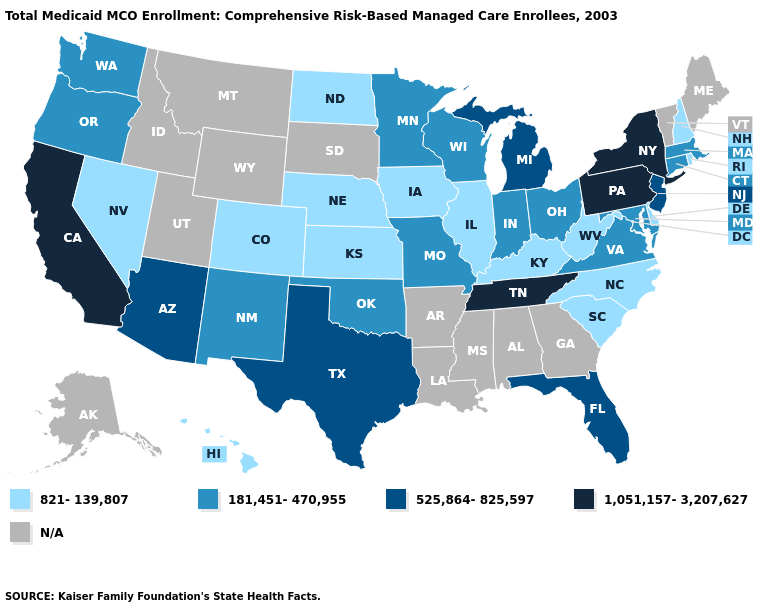Which states have the highest value in the USA?
Give a very brief answer. California, New York, Pennsylvania, Tennessee. Name the states that have a value in the range 525,864-825,597?
Give a very brief answer. Arizona, Florida, Michigan, New Jersey, Texas. Among the states that border Vermont , does New York have the highest value?
Concise answer only. Yes. What is the value of Nevada?
Answer briefly. 821-139,807. Does North Carolina have the lowest value in the USA?
Write a very short answer. Yes. Which states have the highest value in the USA?
Give a very brief answer. California, New York, Pennsylvania, Tennessee. What is the highest value in states that border Texas?
Short answer required. 181,451-470,955. What is the value of Alabama?
Keep it brief. N/A. What is the value of Arkansas?
Concise answer only. N/A. What is the value of Rhode Island?
Keep it brief. 821-139,807. Name the states that have a value in the range 525,864-825,597?
Keep it brief. Arizona, Florida, Michigan, New Jersey, Texas. What is the value of Arizona?
Write a very short answer. 525,864-825,597. Does New York have the lowest value in the Northeast?
Short answer required. No. Which states have the lowest value in the USA?
Answer briefly. Colorado, Delaware, Hawaii, Illinois, Iowa, Kansas, Kentucky, Nebraska, Nevada, New Hampshire, North Carolina, North Dakota, Rhode Island, South Carolina, West Virginia. 